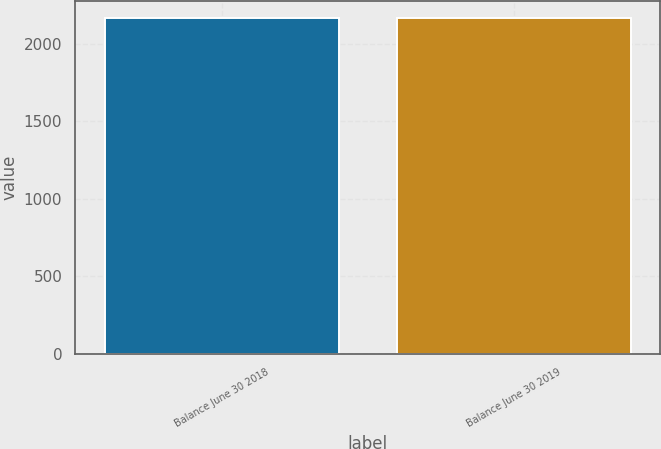Convert chart. <chart><loc_0><loc_0><loc_500><loc_500><bar_chart><fcel>Balance June 30 2018<fcel>Balance June 30 2019<nl><fcel>2167<fcel>2167.1<nl></chart> 